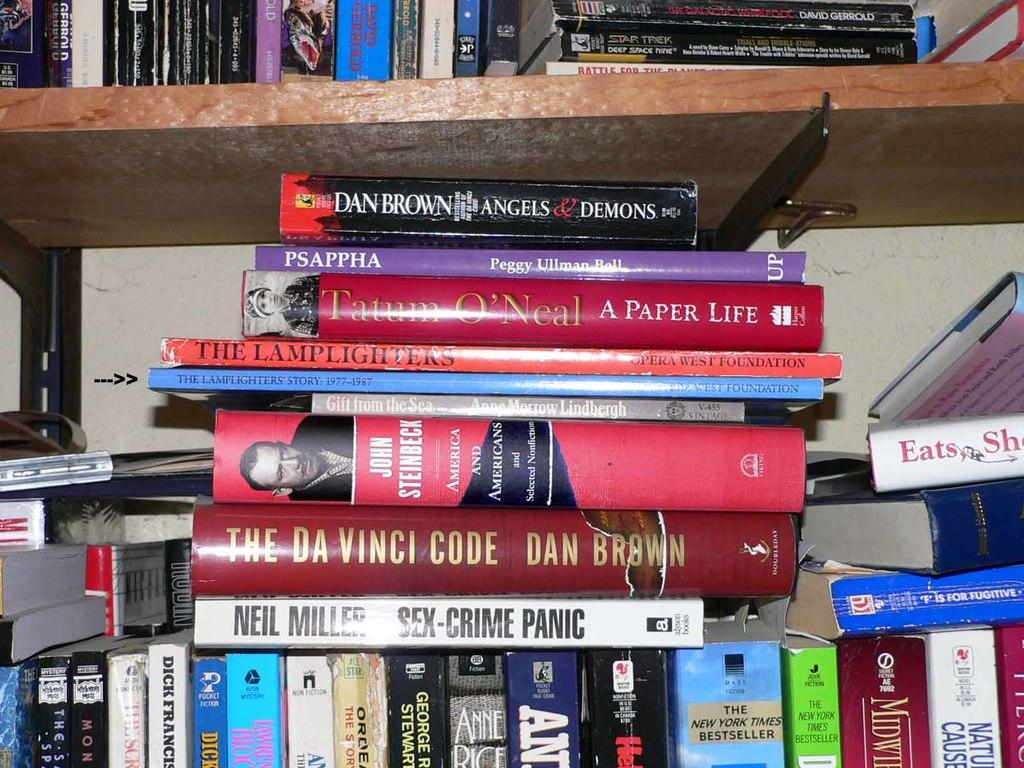Provide a one-sentence caption for the provided image. Many books including, one titled, Angels & Demons, scattered among the shelves. 